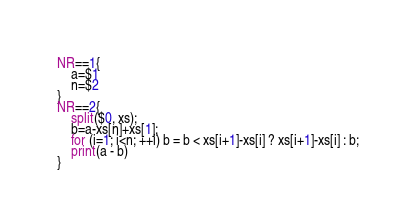Convert code to text. <code><loc_0><loc_0><loc_500><loc_500><_Awk_>NR==1{
    a=$1
    n=$2
}
NR==2{
    split($0, xs);
    b=a-xs[n]+xs[1];
    for (i=1; i<n; ++i) b = b < xs[i+1]-xs[i] ? xs[i+1]-xs[i] : b;
    print(a - b)
}
</code> 